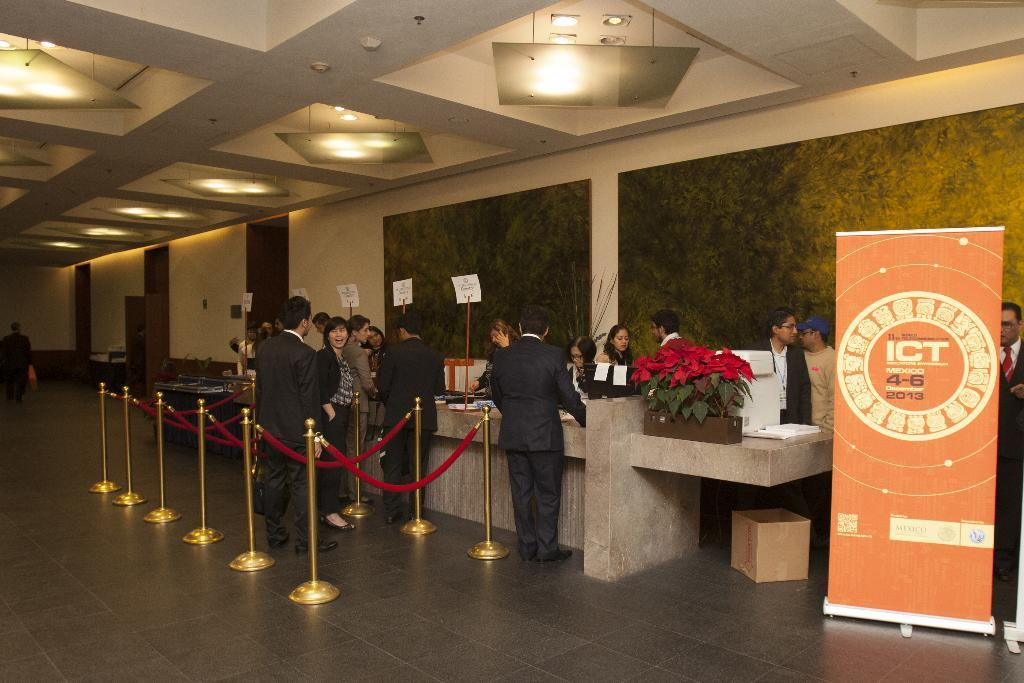How many people are present in the image? There are many people in the image. What are the people doing in the image? The people are standing near a reception. What is the surface beneath the people's feet in the image? There is a floor at the bottom of the image. What can be seen behind the people in the image? There is a wall in the background of the image. What is above the people in the image? There is a roof at the top of the image. Can you describe the lighting conditions in the image? There is light visible in the image. What year is depicted in the image? The image does not depict a specific year; it is a photograph of a current event. What type of game are the people playing in the image? There is no game being played in the image; the people are standing near a reception. 